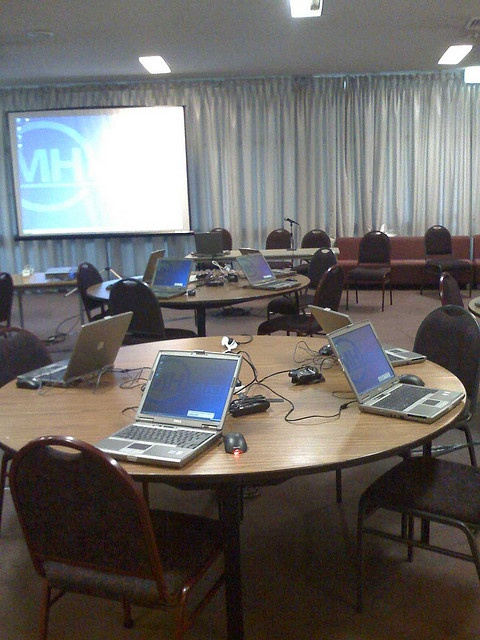Describe the objects in this image and their specific colors. I can see chair in gray, black, maroon, and tan tones, tv in gray, white, lightblue, and darkgray tones, dining table in gray, black, and tan tones, dining table in gray and tan tones, and chair in gray and black tones in this image. 